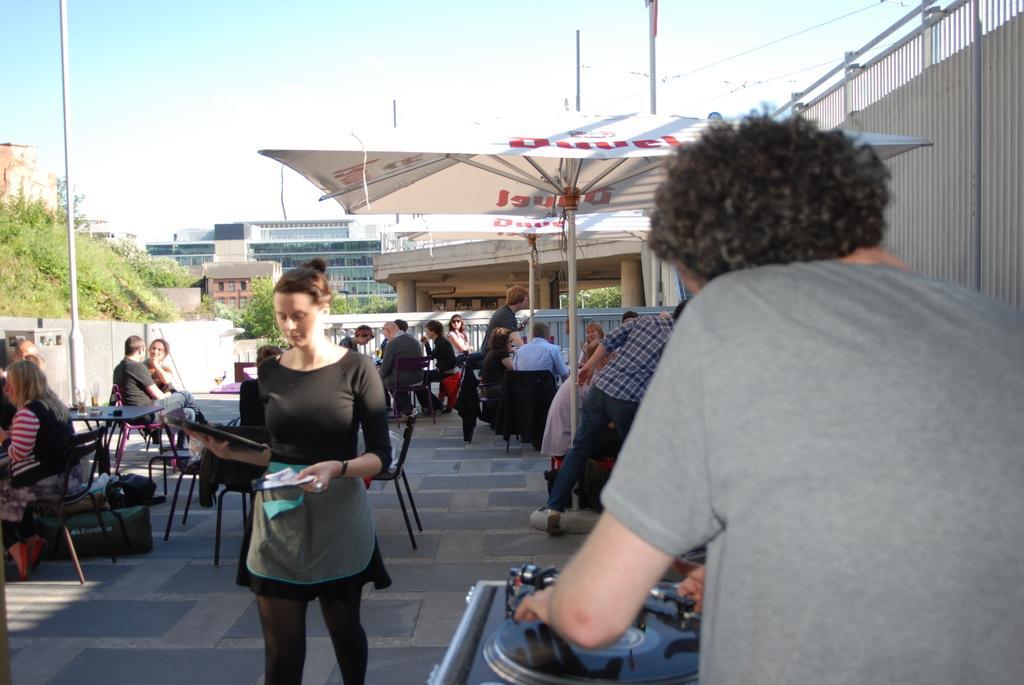How would you summarize this image in a sentence or two? In this image we can see some buildings, some trees, some plants, some bushes on the surface, some poles, two tents with poles, some wires, some objects are on the surface, some people are sitting on the chairs, some objects are on the tables, some people are standing, one woman walking and holding some objects. There are some people holding some objects, one man playing music and at the top there is the sky. 